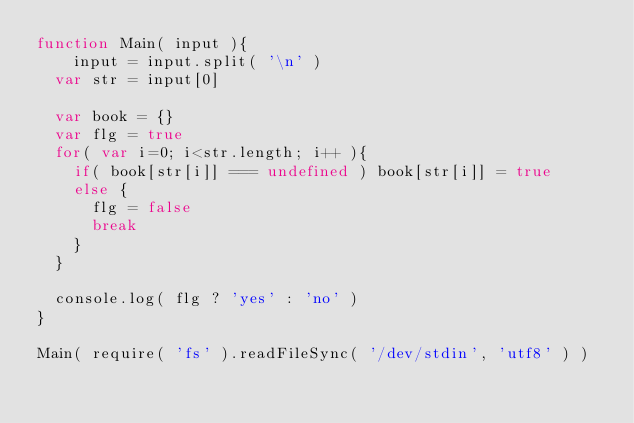Convert code to text. <code><loc_0><loc_0><loc_500><loc_500><_JavaScript_>function Main( input ){
	input = input.split( '\n' )
  var str = input[0]

  var book = {}
  var flg = true
  for( var i=0; i<str.length; i++ ){
    if( book[str[i]] === undefined ) book[str[i]] = true
    else {
      flg = false
      break
    }
  }

  console.log( flg ? 'yes' : 'no' )
}

Main( require( 'fs' ).readFileSync( '/dev/stdin', 'utf8' ) )
</code> 